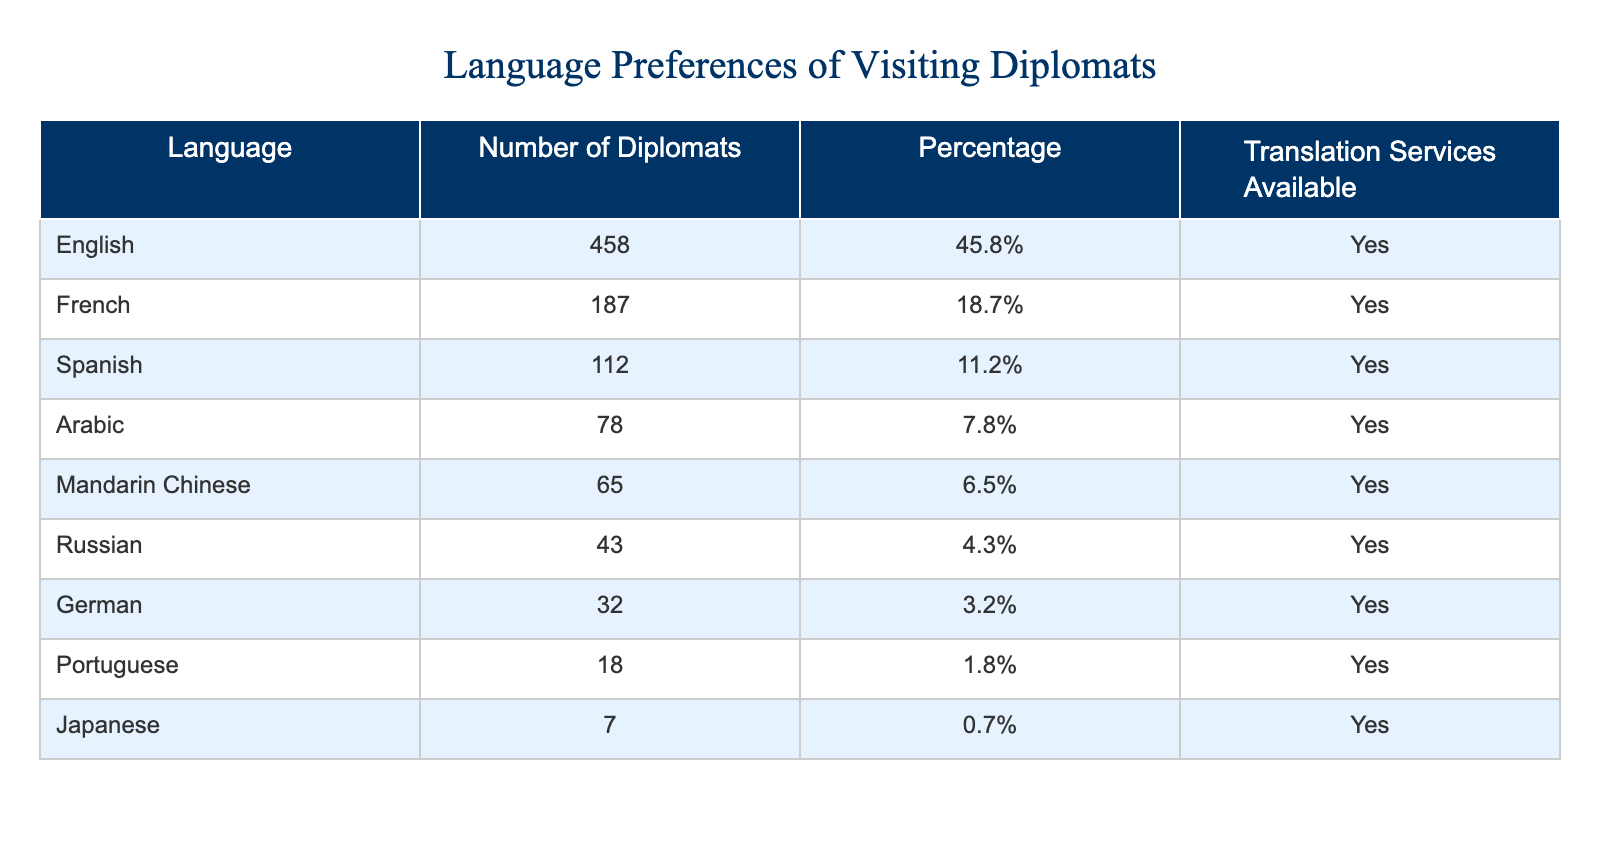What is the most preferred language among visiting diplomats? The table shows the number of diplomats preferring each language. English has the highest count at 458, compared to other languages.
Answer: English How many diplomats prefer Spanish? Referring to the table, the row for Spanish lists the number of diplomats as 112.
Answer: 112 Is there translation services available for Mandarin Chinese? The table indicates that translation services are available for Mandarin Chinese, as marked under the "Translation Services Available" column.
Answer: Yes What percentage of diplomats speak Arabic? The table shows that 78 diplomats speak Arabic, which is represented as 7.8% of the overall total.
Answer: 7.8% Which two languages combined have a higher number of diplomats than French? The number of diplomats preferring Chinese (65) and Russian (43) adds up to 108, which is less than French (187). However, if we consider English (458) with any other language, they will exceed French. Answering this accurately shows that only English surpasses French alone.
Answer: English If we consider all languages excluding English, which language has the greatest number of diplomats? By looking at the table, the greatest number excluding English is French, with 187 diplomats. Other languages have fewer diplomats than this.
Answer: French What is the total percentage of diplomats who prefer languages other than English? To calculate this, sum up the percentages of all languages excluding English, which gives: 18.7% (French) + 11.2% (Spanish) + 7.8% (Arabic) + 6.5% (Mandarin Chinese) + 4.3% (Russian) + 3.2% (German) + 1.8% (Portuguese) + 0.7% (Japanese) = 54.2%.
Answer: 54.2% Are there fewer diplomats who prefer Japanese or Portuguese? The count for Japanese is 7 and for Portuguese is 18. Since 7 is less than 18, the answer is clear.
Answer: Japanese What percentage of all diplomats speak languages other than English and French? To find this percentage, consider those who speak Spanish, Arabic, Mandarin Chinese, Russian, German, Portuguese, and Japanese. Adding these percentages gives 11.2% + 7.8% + 6.5% + 4.3% + 3.2% + 1.8% + 0.7% = 35.5%.
Answer: 35.5% 